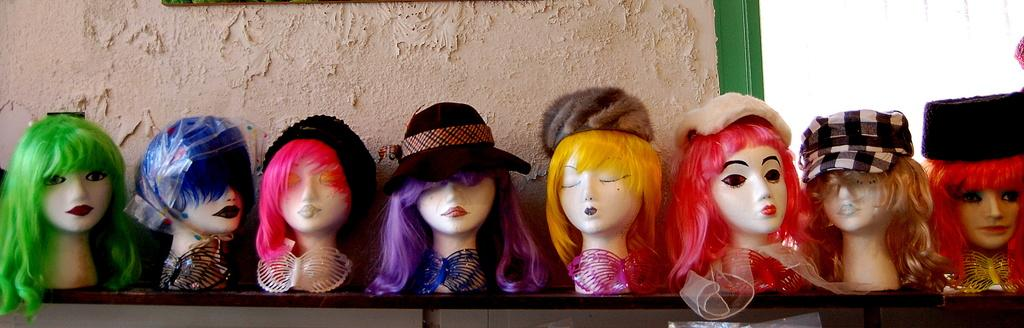What type of objects are featured in the image? There are mannequin faces in the image. What accessories are the mannequin faces wearing? The mannequin faces have wigs and caps. Where are the mannequin faces located? The mannequin faces are on a shelf. What is visible behind the shelf? There is a wall behind the shelf. Can you tell me how many crows are perched on the wall behind the shelf? There are no crows present in the image; it only features mannequin faces with wigs and caps on a shelf. 